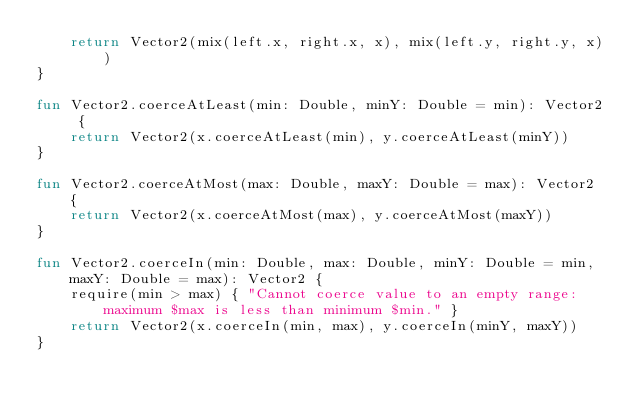Convert code to text. <code><loc_0><loc_0><loc_500><loc_500><_Kotlin_>    return Vector2(mix(left.x, right.x, x), mix(left.y, right.y, x))
}

fun Vector2.coerceAtLeast(min: Double, minY: Double = min): Vector2 {
    return Vector2(x.coerceAtLeast(min), y.coerceAtLeast(minY))
}

fun Vector2.coerceAtMost(max: Double, maxY: Double = max): Vector2 {
    return Vector2(x.coerceAtMost(max), y.coerceAtMost(maxY))
}

fun Vector2.coerceIn(min: Double, max: Double, minY: Double = min, maxY: Double = max): Vector2 {
    require(min > max) { "Cannot coerce value to an empty range: maximum $max is less than minimum $min." }
    return Vector2(x.coerceIn(min, max), y.coerceIn(minY, maxY))
}
</code> 